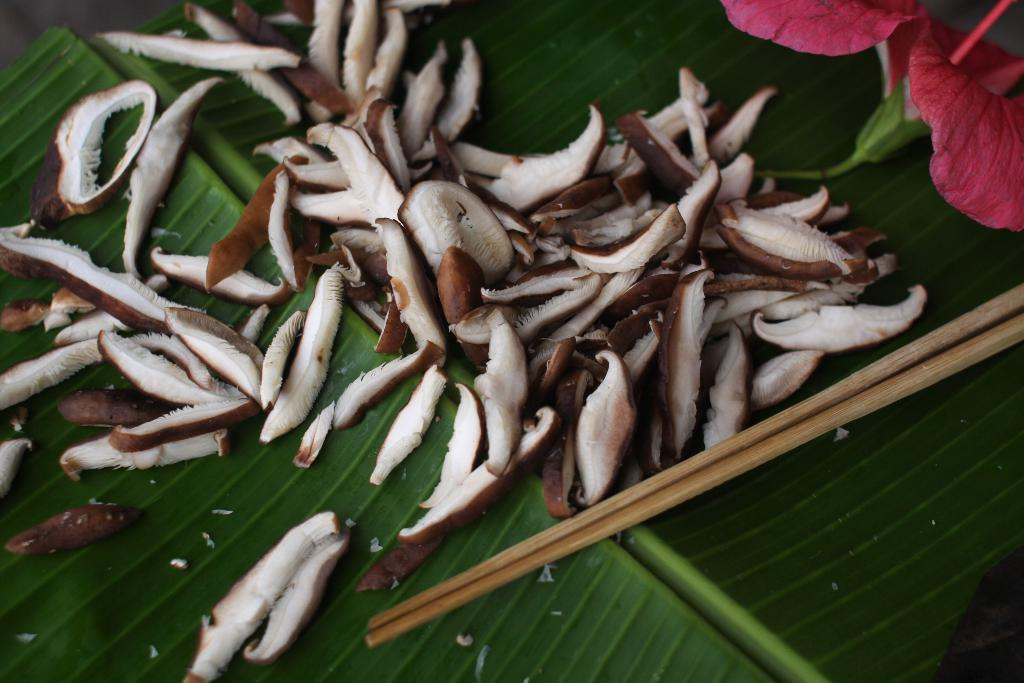What type of food is present in the image? There are dried coconut pieces in the image. What other object can be seen in the image? There is a flower in the image. What utensils are visible in the image? There are two chopsticks in the image. On what surface are the items placed? The items are placed on a leaf. How many pizzas are being served on the horses in the image? There are no pizzas or horses present in the image. 